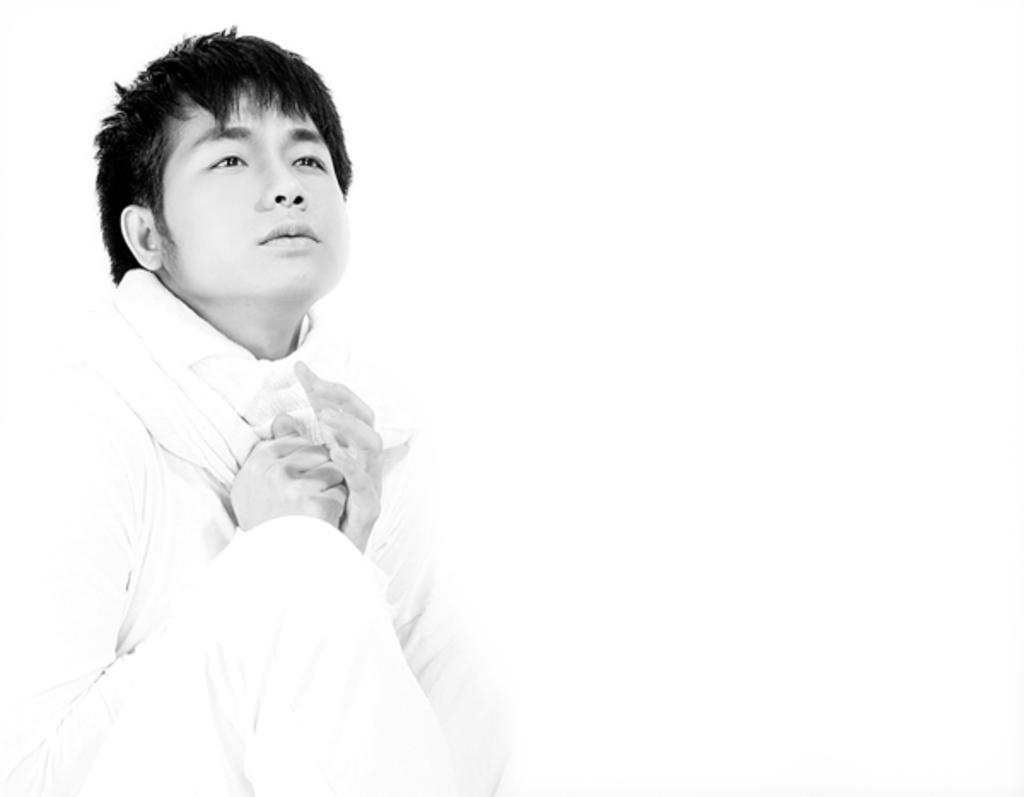Who is present in the image? There is a man in the image. What is the man wearing? The man is wearing clothes. What color is the background of the image? The background of the image is white. What type of image is this, in terms of color? The image is black and white. What type of pen is the man holding in the image? There is no pen present in the image. What time of day is depicted in the image? The image does not depict a specific time of day, as it is black and white and lacks any contextual clues. 